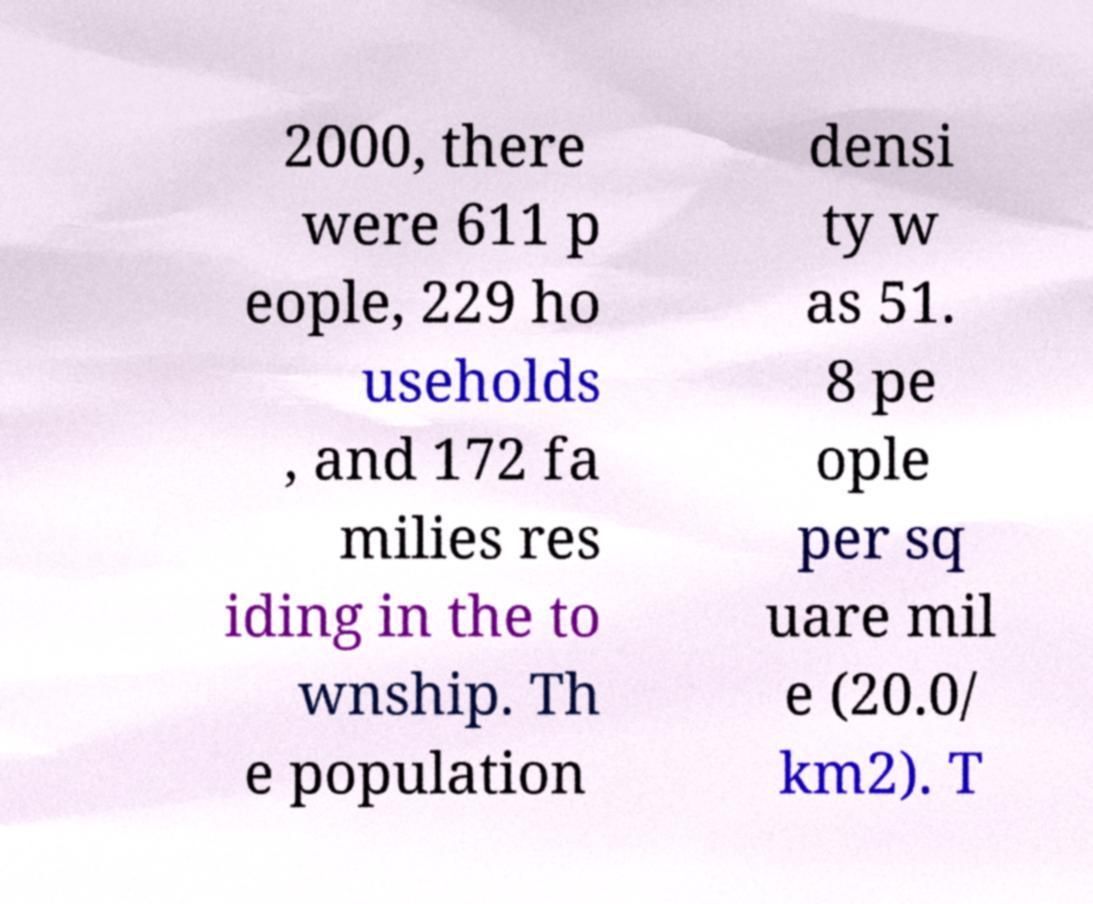What messages or text are displayed in this image? I need them in a readable, typed format. 2000, there were 611 p eople, 229 ho useholds , and 172 fa milies res iding in the to wnship. Th e population densi ty w as 51. 8 pe ople per sq uare mil e (20.0/ km2). T 